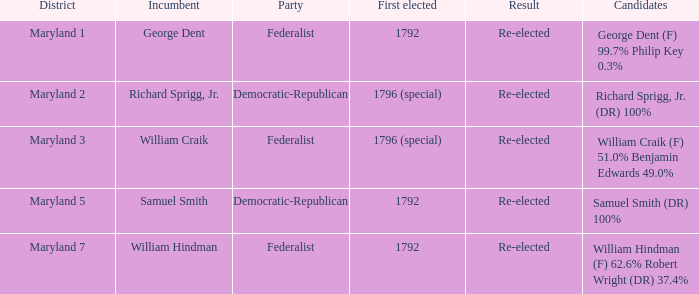Who are the aspirants for maryland's 1st district? George Dent (F) 99.7% Philip Key 0.3%. 